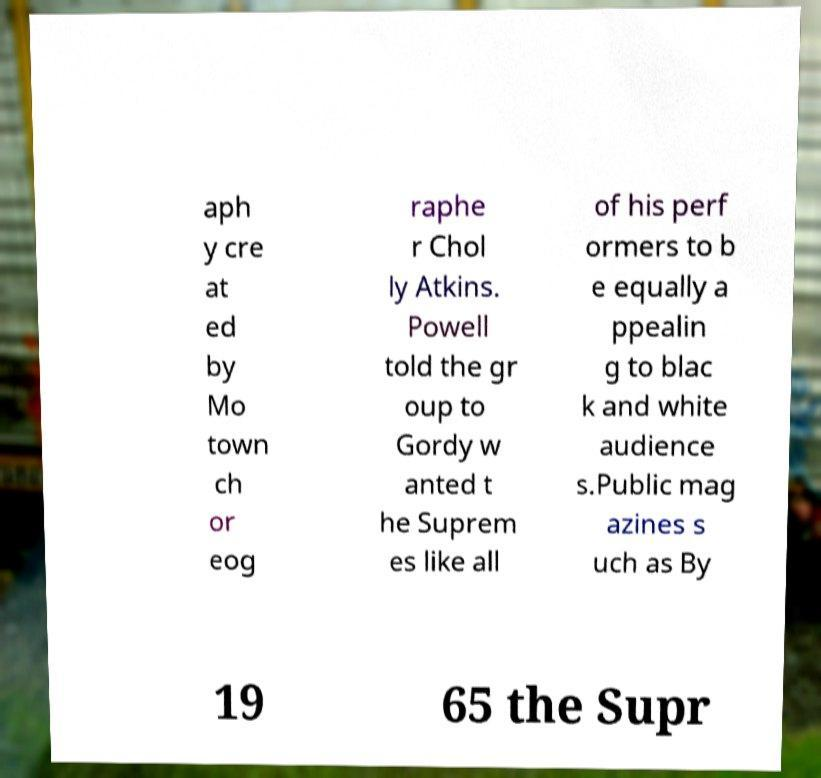Please read and relay the text visible in this image. What does it say? aph y cre at ed by Mo town ch or eog raphe r Chol ly Atkins. Powell told the gr oup to Gordy w anted t he Suprem es like all of his perf ormers to b e equally a ppealin g to blac k and white audience s.Public mag azines s uch as By 19 65 the Supr 